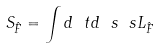<formula> <loc_0><loc_0><loc_500><loc_500>S _ { \hat { F } } = \int d \ t d \ s \ s L _ { \hat { F } }</formula> 